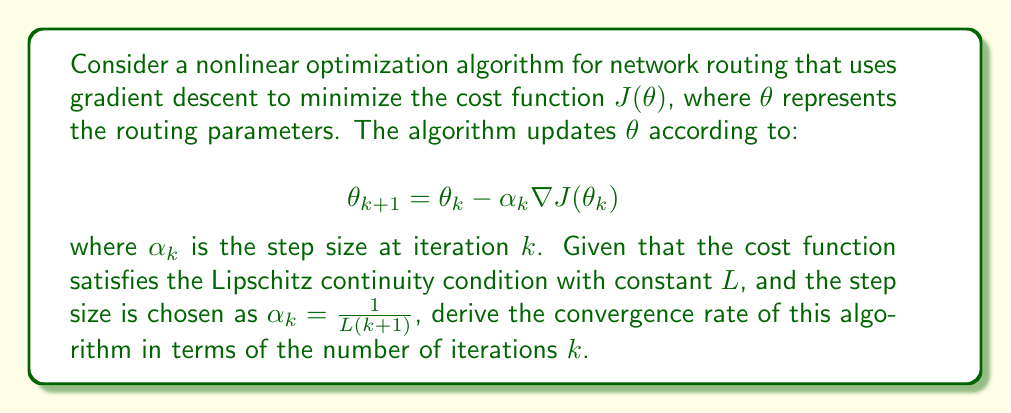Solve this math problem. To analyze the convergence rate, we'll follow these steps:

1) First, recall the convergence theorem for gradient descent with a Lipschitz continuous objective function:

   $$J(\theta_{k+1}) - J(\theta^*) \leq \frac{L\|\theta_0 - \theta^*\|^2}{2(k+1)}$$

   where $\theta^*$ is the optimal solution.

2) Given the step size $\alpha_k = \frac{1}{L(k+1)}$, we can see that this matches the conditions for the theorem above.

3) The convergence rate is determined by how quickly the right-hand side of the inequality approaches zero as $k$ increases.

4) We can express this as:

   $$J(\theta_k) - J(\theta^*) = O(\frac{1}{k})$$

5) In big O notation, this indicates that the algorithm converges at a rate of $O(\frac{1}{k})$.

6) For a software engineer working on protocol design, this means that to reduce the error by a factor of 10, you would need to increase the number of iterations by a factor of 10.

7) In practice, this convergence rate is considered relatively slow, especially for large-scale network routing problems where quick adaptation is crucial.
Answer: $O(\frac{1}{k})$ 